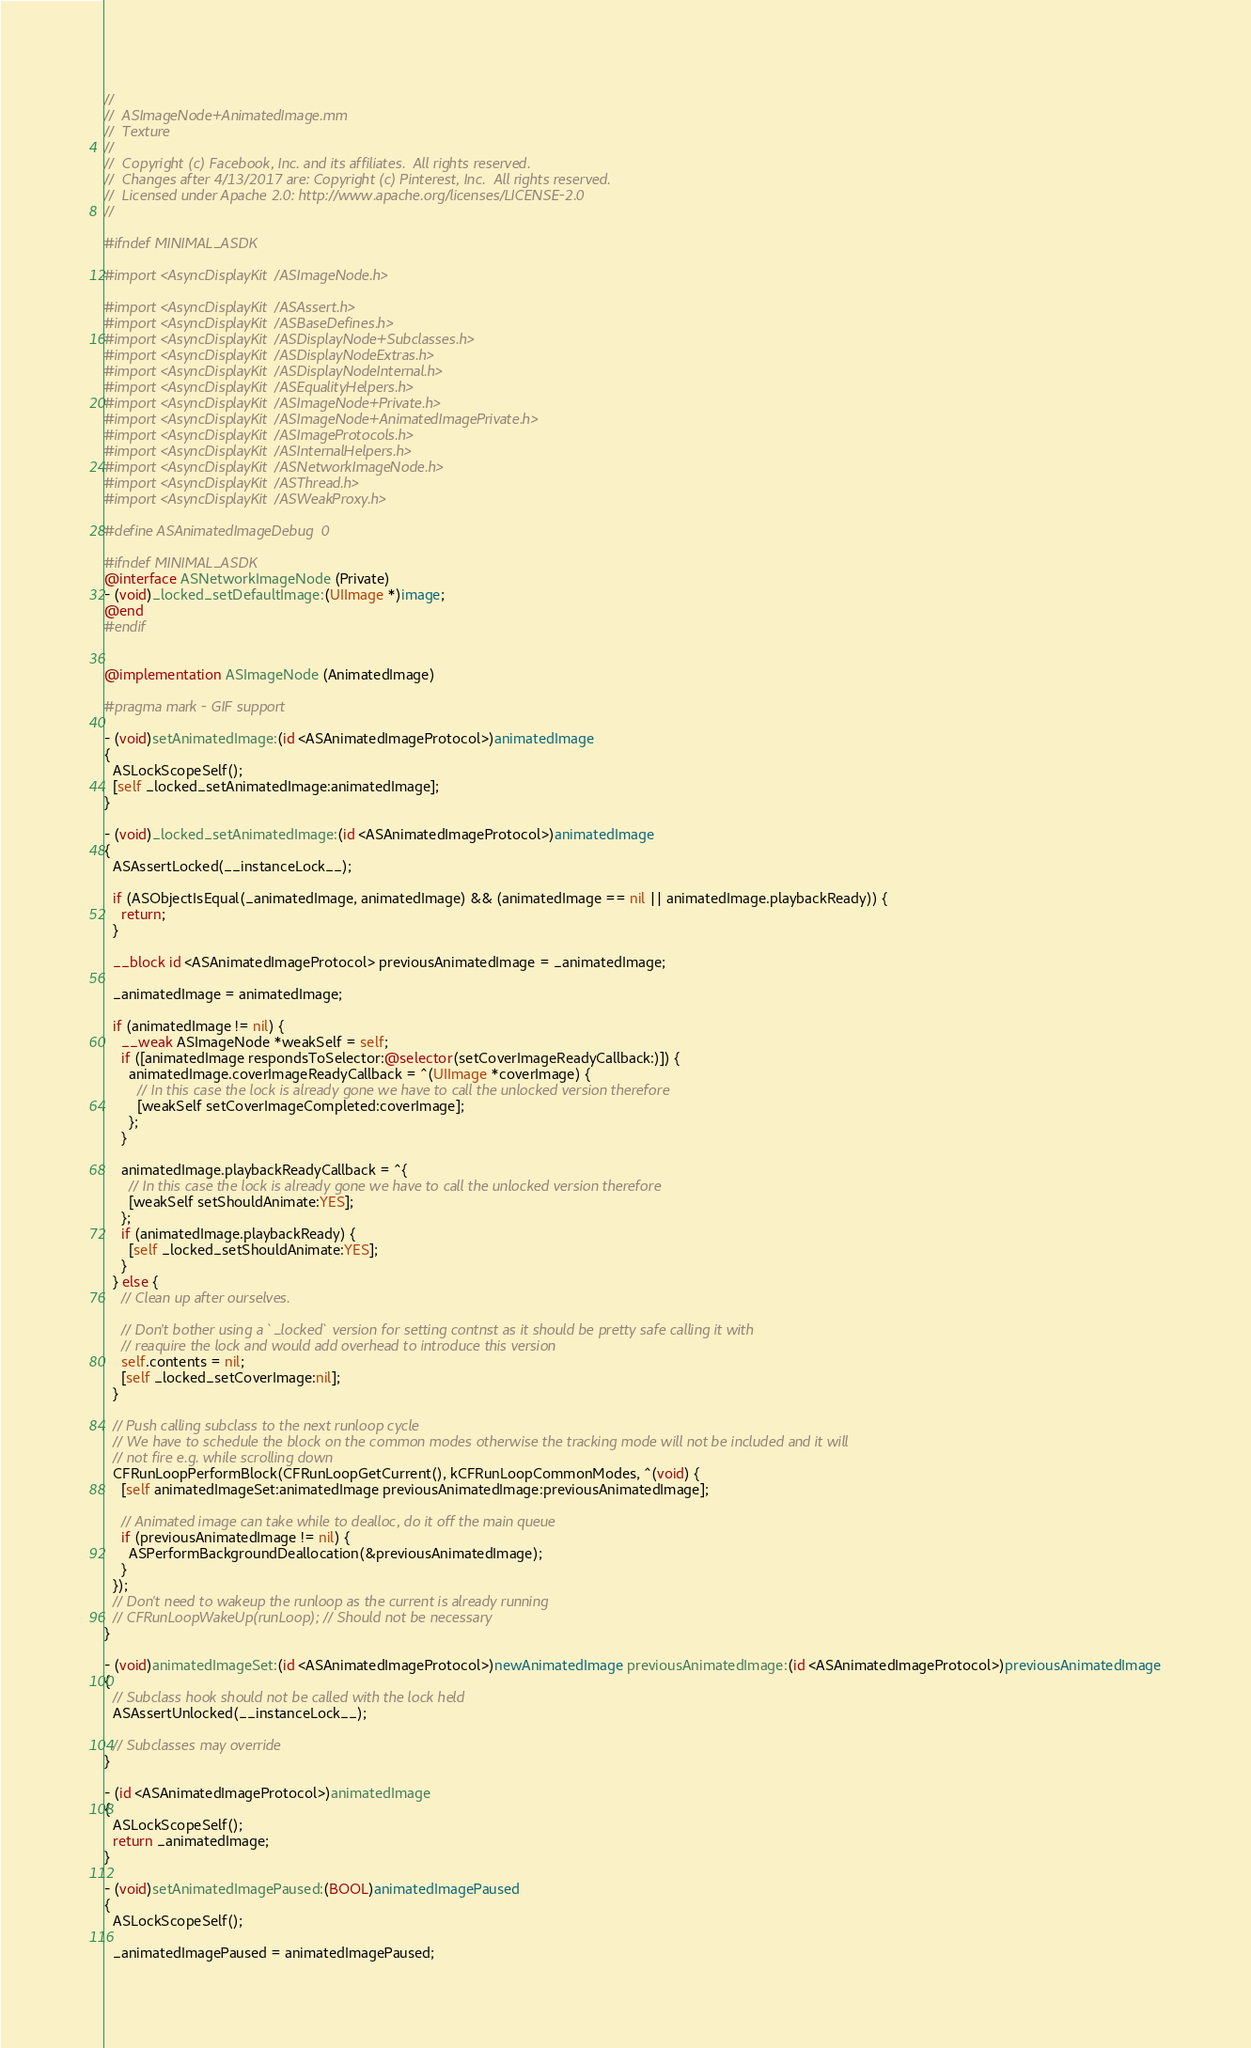Convert code to text. <code><loc_0><loc_0><loc_500><loc_500><_ObjectiveC_>//
//  ASImageNode+AnimatedImage.mm
//  Texture
//
//  Copyright (c) Facebook, Inc. and its affiliates.  All rights reserved.
//  Changes after 4/13/2017 are: Copyright (c) Pinterest, Inc.  All rights reserved.
//  Licensed under Apache 2.0: http://www.apache.org/licenses/LICENSE-2.0
//

#ifndef MINIMAL_ASDK

#import <AsyncDisplayKit/ASImageNode.h>

#import <AsyncDisplayKit/ASAssert.h>
#import <AsyncDisplayKit/ASBaseDefines.h>
#import <AsyncDisplayKit/ASDisplayNode+Subclasses.h>
#import <AsyncDisplayKit/ASDisplayNodeExtras.h>
#import <AsyncDisplayKit/ASDisplayNodeInternal.h>
#import <AsyncDisplayKit/ASEqualityHelpers.h>
#import <AsyncDisplayKit/ASImageNode+Private.h>
#import <AsyncDisplayKit/ASImageNode+AnimatedImagePrivate.h>
#import <AsyncDisplayKit/ASImageProtocols.h>
#import <AsyncDisplayKit/ASInternalHelpers.h>
#import <AsyncDisplayKit/ASNetworkImageNode.h>
#import <AsyncDisplayKit/ASThread.h>
#import <AsyncDisplayKit/ASWeakProxy.h>

#define ASAnimatedImageDebug  0

#ifndef MINIMAL_ASDK
@interface ASNetworkImageNode (Private)
- (void)_locked_setDefaultImage:(UIImage *)image;
@end
#endif


@implementation ASImageNode (AnimatedImage)

#pragma mark - GIF support

- (void)setAnimatedImage:(id <ASAnimatedImageProtocol>)animatedImage
{
  ASLockScopeSelf();
  [self _locked_setAnimatedImage:animatedImage];
}

- (void)_locked_setAnimatedImage:(id <ASAnimatedImageProtocol>)animatedImage
{
  ASAssertLocked(__instanceLock__);

  if (ASObjectIsEqual(_animatedImage, animatedImage) && (animatedImage == nil || animatedImage.playbackReady)) {
    return;
  }
  
  __block id <ASAnimatedImageProtocol> previousAnimatedImage = _animatedImage;
  
  _animatedImage = animatedImage;
  
  if (animatedImage != nil) {
    __weak ASImageNode *weakSelf = self;
    if ([animatedImage respondsToSelector:@selector(setCoverImageReadyCallback:)]) {
      animatedImage.coverImageReadyCallback = ^(UIImage *coverImage) {
        // In this case the lock is already gone we have to call the unlocked version therefore
        [weakSelf setCoverImageCompleted:coverImage];
      };
    }
    
    animatedImage.playbackReadyCallback = ^{
      // In this case the lock is already gone we have to call the unlocked version therefore
      [weakSelf setShouldAnimate:YES];
    };
    if (animatedImage.playbackReady) {
      [self _locked_setShouldAnimate:YES];
    }
  } else {
    // Clean up after ourselves.
    
    // Don't bother using a `_locked` version for setting contnst as it should be pretty safe calling it with
    // reaquire the lock and would add overhead to introduce this version
    self.contents = nil;
    [self _locked_setCoverImage:nil];
  }

  // Push calling subclass to the next runloop cycle
  // We have to schedule the block on the common modes otherwise the tracking mode will not be included and it will
  // not fire e.g. while scrolling down
  CFRunLoopPerformBlock(CFRunLoopGetCurrent(), kCFRunLoopCommonModes, ^(void) {
    [self animatedImageSet:animatedImage previousAnimatedImage:previousAnimatedImage];

    // Animated image can take while to dealloc, do it off the main queue
    if (previousAnimatedImage != nil) {
      ASPerformBackgroundDeallocation(&previousAnimatedImage);
    }
  });
  // Don't need to wakeup the runloop as the current is already running
  // CFRunLoopWakeUp(runLoop); // Should not be necessary
}

- (void)animatedImageSet:(id <ASAnimatedImageProtocol>)newAnimatedImage previousAnimatedImage:(id <ASAnimatedImageProtocol>)previousAnimatedImage
{
  // Subclass hook should not be called with the lock held
  ASAssertUnlocked(__instanceLock__);
  
  // Subclasses may override
}

- (id <ASAnimatedImageProtocol>)animatedImage
{
  ASLockScopeSelf();
  return _animatedImage;
}

- (void)setAnimatedImagePaused:(BOOL)animatedImagePaused
{
  ASLockScopeSelf();

  _animatedImagePaused = animatedImagePaused;
</code> 